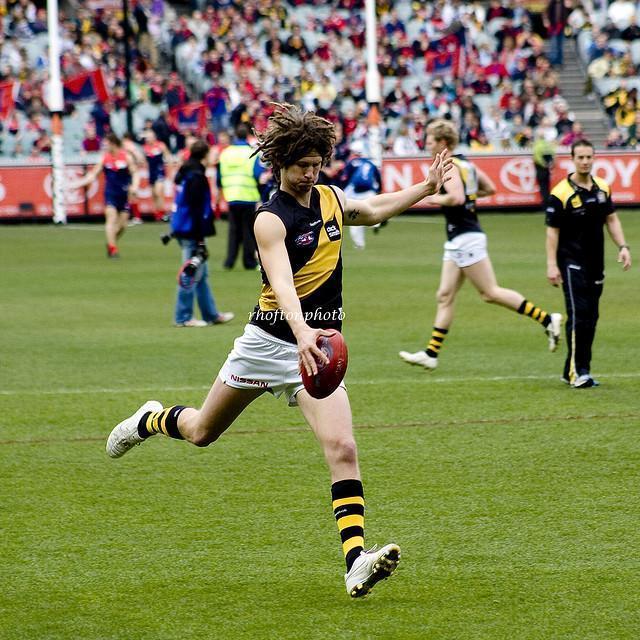How many people are there?
Give a very brief answer. 7. How many giraffes can be seen?
Give a very brief answer. 0. 